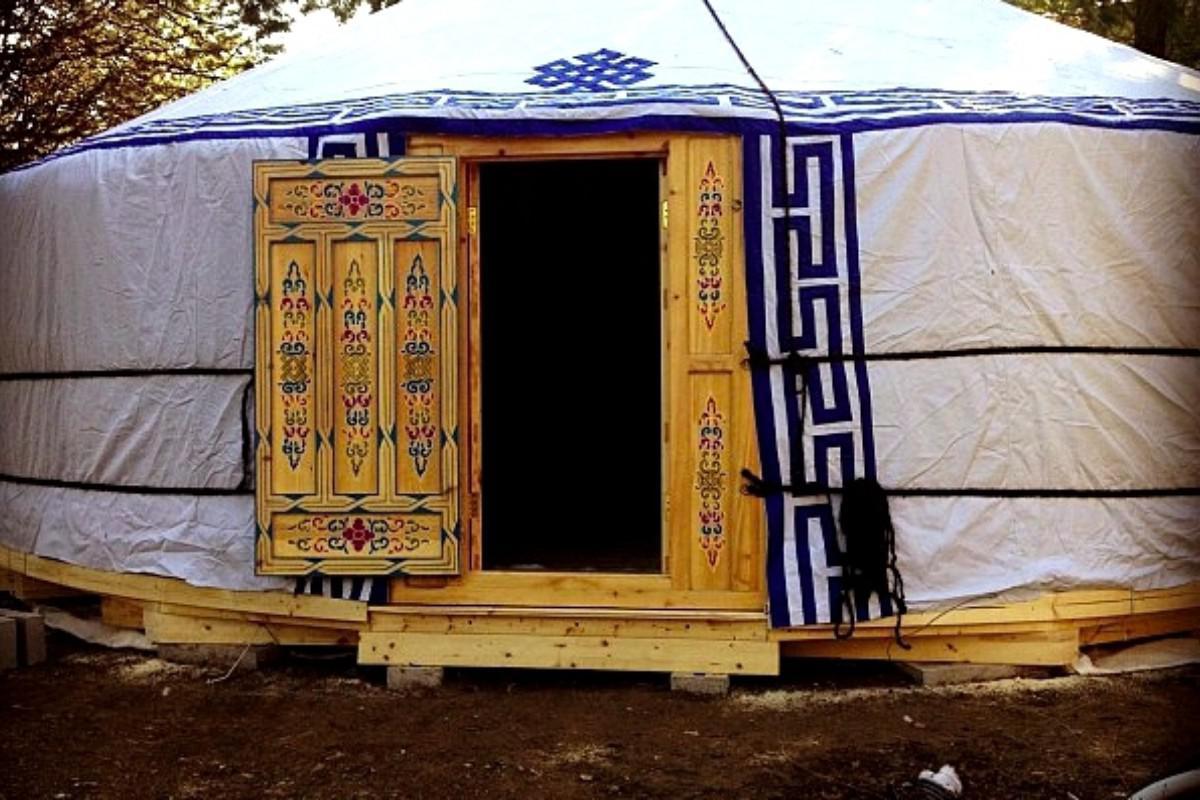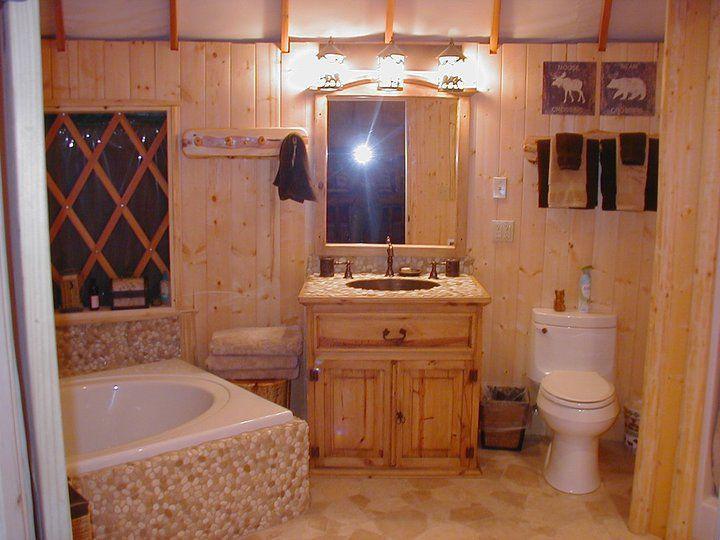The first image is the image on the left, the second image is the image on the right. For the images shown, is this caption "A room with a fan-like ceiling contains an over-stuffed beige couch facing a fireplace with flame-glow in it." true? Answer yes or no. No. 